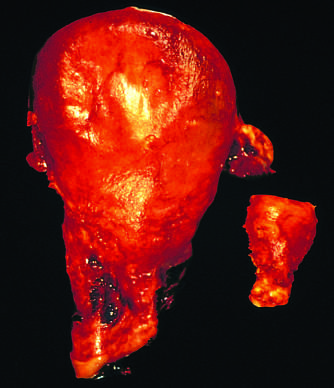what was a gravid uterus removed for?
Answer the question using a single word or phrase. Postpartum bleeding 